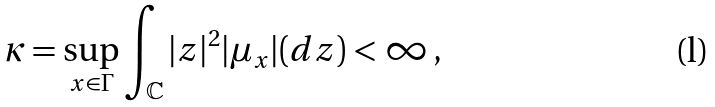Convert formula to latex. <formula><loc_0><loc_0><loc_500><loc_500>\kappa = \sup _ { x \in \Gamma } \int _ { \mathbb { C } } | z | ^ { 2 } | \mu _ { x } | ( d z ) < \infty \, ,</formula> 